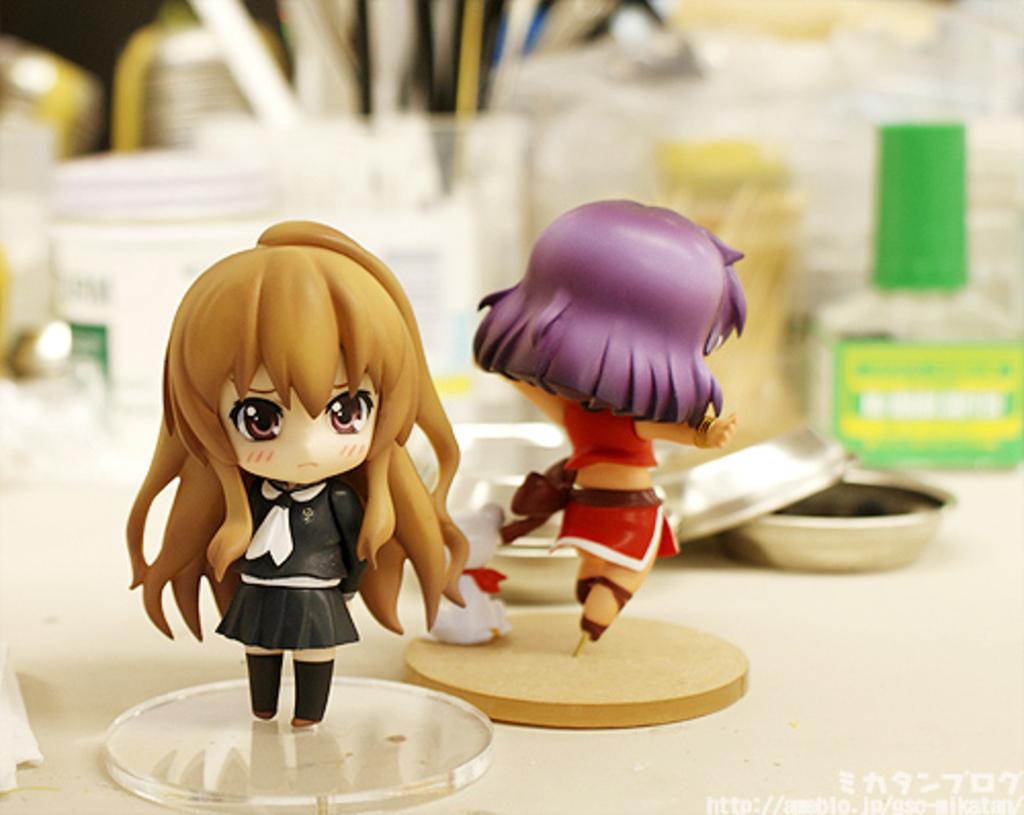What type of dolls are in the image? There are two girl dolls in the image. Where are the dolls located? The dolls are on a ground substance. What can be seen in the image besides the dolls? There are bottles with green color caps and bowls in the image. What type of suit is the pig wearing in the image? There is no pig present in the image, and therefore no suit can be observed. 